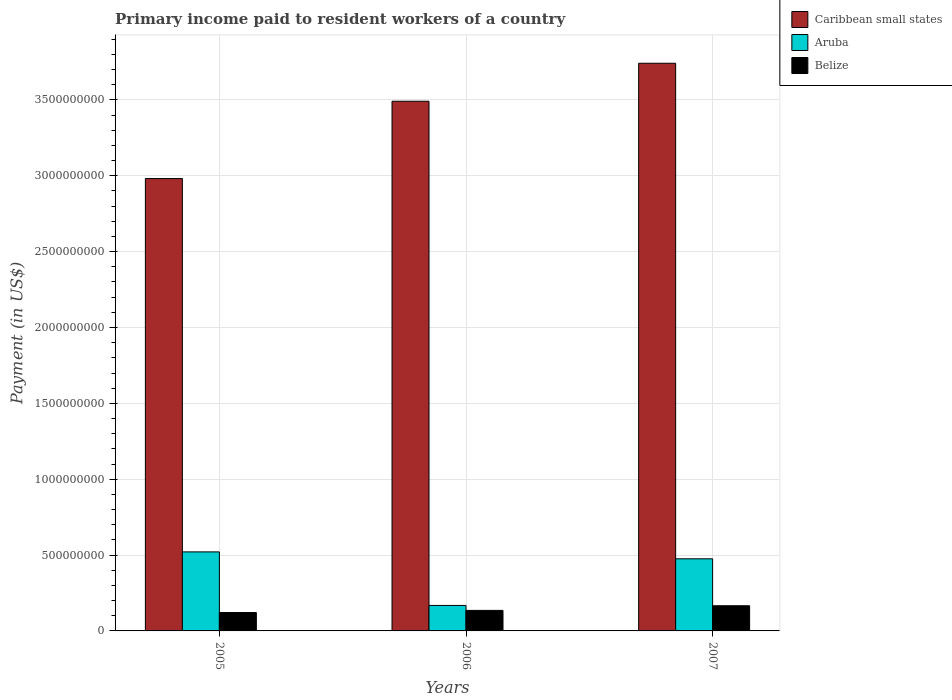How many different coloured bars are there?
Your answer should be very brief. 3. How many bars are there on the 2nd tick from the left?
Your response must be concise. 3. How many bars are there on the 2nd tick from the right?
Your answer should be compact. 3. What is the amount paid to workers in Caribbean small states in 2006?
Keep it short and to the point. 3.49e+09. Across all years, what is the maximum amount paid to workers in Caribbean small states?
Keep it short and to the point. 3.74e+09. Across all years, what is the minimum amount paid to workers in Caribbean small states?
Provide a short and direct response. 2.98e+09. What is the total amount paid to workers in Caribbean small states in the graph?
Your response must be concise. 1.02e+1. What is the difference between the amount paid to workers in Caribbean small states in 2005 and that in 2007?
Your answer should be compact. -7.60e+08. What is the difference between the amount paid to workers in Aruba in 2005 and the amount paid to workers in Belize in 2006?
Offer a very short reply. 3.86e+08. What is the average amount paid to workers in Caribbean small states per year?
Provide a succinct answer. 3.41e+09. In the year 2007, what is the difference between the amount paid to workers in Caribbean small states and amount paid to workers in Aruba?
Provide a short and direct response. 3.27e+09. What is the ratio of the amount paid to workers in Aruba in 2005 to that in 2006?
Provide a succinct answer. 3.1. Is the difference between the amount paid to workers in Caribbean small states in 2005 and 2006 greater than the difference between the amount paid to workers in Aruba in 2005 and 2006?
Your response must be concise. No. What is the difference between the highest and the second highest amount paid to workers in Belize?
Offer a terse response. 3.05e+07. What is the difference between the highest and the lowest amount paid to workers in Aruba?
Keep it short and to the point. 3.53e+08. In how many years, is the amount paid to workers in Caribbean small states greater than the average amount paid to workers in Caribbean small states taken over all years?
Your answer should be very brief. 2. What does the 1st bar from the left in 2005 represents?
Offer a terse response. Caribbean small states. What does the 3rd bar from the right in 2007 represents?
Your response must be concise. Caribbean small states. How many bars are there?
Offer a very short reply. 9. Are all the bars in the graph horizontal?
Offer a very short reply. No. What is the difference between two consecutive major ticks on the Y-axis?
Make the answer very short. 5.00e+08. Does the graph contain grids?
Keep it short and to the point. Yes. Where does the legend appear in the graph?
Ensure brevity in your answer.  Top right. How many legend labels are there?
Offer a very short reply. 3. How are the legend labels stacked?
Ensure brevity in your answer.  Vertical. What is the title of the graph?
Your answer should be compact. Primary income paid to resident workers of a country. What is the label or title of the Y-axis?
Provide a short and direct response. Payment (in US$). What is the Payment (in US$) in Caribbean small states in 2005?
Provide a succinct answer. 2.98e+09. What is the Payment (in US$) in Aruba in 2005?
Offer a very short reply. 5.21e+08. What is the Payment (in US$) in Belize in 2005?
Your answer should be compact. 1.21e+08. What is the Payment (in US$) in Caribbean small states in 2006?
Offer a very short reply. 3.49e+09. What is the Payment (in US$) in Aruba in 2006?
Provide a succinct answer. 1.68e+08. What is the Payment (in US$) in Belize in 2006?
Keep it short and to the point. 1.35e+08. What is the Payment (in US$) in Caribbean small states in 2007?
Keep it short and to the point. 3.74e+09. What is the Payment (in US$) of Aruba in 2007?
Your answer should be compact. 4.75e+08. What is the Payment (in US$) in Belize in 2007?
Make the answer very short. 1.66e+08. Across all years, what is the maximum Payment (in US$) of Caribbean small states?
Your response must be concise. 3.74e+09. Across all years, what is the maximum Payment (in US$) of Aruba?
Offer a very short reply. 5.21e+08. Across all years, what is the maximum Payment (in US$) of Belize?
Make the answer very short. 1.66e+08. Across all years, what is the minimum Payment (in US$) of Caribbean small states?
Give a very brief answer. 2.98e+09. Across all years, what is the minimum Payment (in US$) in Aruba?
Offer a very short reply. 1.68e+08. Across all years, what is the minimum Payment (in US$) in Belize?
Keep it short and to the point. 1.21e+08. What is the total Payment (in US$) in Caribbean small states in the graph?
Your answer should be compact. 1.02e+1. What is the total Payment (in US$) in Aruba in the graph?
Your response must be concise. 1.16e+09. What is the total Payment (in US$) of Belize in the graph?
Keep it short and to the point. 4.23e+08. What is the difference between the Payment (in US$) in Caribbean small states in 2005 and that in 2006?
Give a very brief answer. -5.10e+08. What is the difference between the Payment (in US$) in Aruba in 2005 and that in 2006?
Ensure brevity in your answer.  3.53e+08. What is the difference between the Payment (in US$) of Belize in 2005 and that in 2006?
Keep it short and to the point. -1.42e+07. What is the difference between the Payment (in US$) in Caribbean small states in 2005 and that in 2007?
Ensure brevity in your answer.  -7.60e+08. What is the difference between the Payment (in US$) in Aruba in 2005 and that in 2007?
Keep it short and to the point. 4.55e+07. What is the difference between the Payment (in US$) in Belize in 2005 and that in 2007?
Keep it short and to the point. -4.47e+07. What is the difference between the Payment (in US$) in Caribbean small states in 2006 and that in 2007?
Offer a terse response. -2.50e+08. What is the difference between the Payment (in US$) of Aruba in 2006 and that in 2007?
Provide a short and direct response. -3.07e+08. What is the difference between the Payment (in US$) in Belize in 2006 and that in 2007?
Your response must be concise. -3.05e+07. What is the difference between the Payment (in US$) in Caribbean small states in 2005 and the Payment (in US$) in Aruba in 2006?
Give a very brief answer. 2.81e+09. What is the difference between the Payment (in US$) of Caribbean small states in 2005 and the Payment (in US$) of Belize in 2006?
Provide a succinct answer. 2.85e+09. What is the difference between the Payment (in US$) in Aruba in 2005 and the Payment (in US$) in Belize in 2006?
Ensure brevity in your answer.  3.86e+08. What is the difference between the Payment (in US$) of Caribbean small states in 2005 and the Payment (in US$) of Aruba in 2007?
Your response must be concise. 2.51e+09. What is the difference between the Payment (in US$) of Caribbean small states in 2005 and the Payment (in US$) of Belize in 2007?
Provide a short and direct response. 2.82e+09. What is the difference between the Payment (in US$) of Aruba in 2005 and the Payment (in US$) of Belize in 2007?
Your response must be concise. 3.55e+08. What is the difference between the Payment (in US$) in Caribbean small states in 2006 and the Payment (in US$) in Aruba in 2007?
Give a very brief answer. 3.02e+09. What is the difference between the Payment (in US$) in Caribbean small states in 2006 and the Payment (in US$) in Belize in 2007?
Your answer should be very brief. 3.33e+09. What is the difference between the Payment (in US$) of Aruba in 2006 and the Payment (in US$) of Belize in 2007?
Ensure brevity in your answer.  2.15e+06. What is the average Payment (in US$) of Caribbean small states per year?
Your response must be concise. 3.41e+09. What is the average Payment (in US$) of Aruba per year?
Give a very brief answer. 3.88e+08. What is the average Payment (in US$) of Belize per year?
Provide a short and direct response. 1.41e+08. In the year 2005, what is the difference between the Payment (in US$) in Caribbean small states and Payment (in US$) in Aruba?
Give a very brief answer. 2.46e+09. In the year 2005, what is the difference between the Payment (in US$) in Caribbean small states and Payment (in US$) in Belize?
Offer a terse response. 2.86e+09. In the year 2005, what is the difference between the Payment (in US$) of Aruba and Payment (in US$) of Belize?
Provide a succinct answer. 4.00e+08. In the year 2006, what is the difference between the Payment (in US$) in Caribbean small states and Payment (in US$) in Aruba?
Your answer should be very brief. 3.32e+09. In the year 2006, what is the difference between the Payment (in US$) in Caribbean small states and Payment (in US$) in Belize?
Keep it short and to the point. 3.36e+09. In the year 2006, what is the difference between the Payment (in US$) in Aruba and Payment (in US$) in Belize?
Provide a succinct answer. 3.27e+07. In the year 2007, what is the difference between the Payment (in US$) of Caribbean small states and Payment (in US$) of Aruba?
Give a very brief answer. 3.27e+09. In the year 2007, what is the difference between the Payment (in US$) of Caribbean small states and Payment (in US$) of Belize?
Offer a very short reply. 3.58e+09. In the year 2007, what is the difference between the Payment (in US$) of Aruba and Payment (in US$) of Belize?
Ensure brevity in your answer.  3.09e+08. What is the ratio of the Payment (in US$) in Caribbean small states in 2005 to that in 2006?
Offer a very short reply. 0.85. What is the ratio of the Payment (in US$) of Aruba in 2005 to that in 2006?
Your response must be concise. 3.1. What is the ratio of the Payment (in US$) in Belize in 2005 to that in 2006?
Give a very brief answer. 0.9. What is the ratio of the Payment (in US$) of Caribbean small states in 2005 to that in 2007?
Your response must be concise. 0.8. What is the ratio of the Payment (in US$) of Aruba in 2005 to that in 2007?
Offer a terse response. 1.1. What is the ratio of the Payment (in US$) of Belize in 2005 to that in 2007?
Your answer should be compact. 0.73. What is the ratio of the Payment (in US$) of Caribbean small states in 2006 to that in 2007?
Offer a terse response. 0.93. What is the ratio of the Payment (in US$) of Aruba in 2006 to that in 2007?
Offer a very short reply. 0.35. What is the ratio of the Payment (in US$) of Belize in 2006 to that in 2007?
Provide a short and direct response. 0.82. What is the difference between the highest and the second highest Payment (in US$) of Caribbean small states?
Make the answer very short. 2.50e+08. What is the difference between the highest and the second highest Payment (in US$) of Aruba?
Your response must be concise. 4.55e+07. What is the difference between the highest and the second highest Payment (in US$) in Belize?
Provide a succinct answer. 3.05e+07. What is the difference between the highest and the lowest Payment (in US$) in Caribbean small states?
Your response must be concise. 7.60e+08. What is the difference between the highest and the lowest Payment (in US$) in Aruba?
Give a very brief answer. 3.53e+08. What is the difference between the highest and the lowest Payment (in US$) of Belize?
Provide a succinct answer. 4.47e+07. 